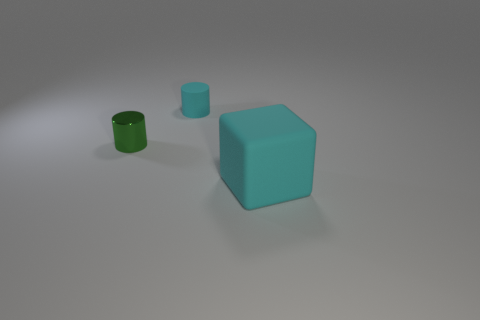Add 1 gray rubber blocks. How many objects exist? 4 Subtract all cylinders. How many objects are left? 1 Subtract 0 blue spheres. How many objects are left? 3 Subtract all brown cylinders. Subtract all blue cubes. How many cylinders are left? 2 Subtract all matte blocks. Subtract all big cyan rubber cubes. How many objects are left? 1 Add 3 matte cubes. How many matte cubes are left? 4 Add 1 gray metallic spheres. How many gray metallic spheres exist? 1 